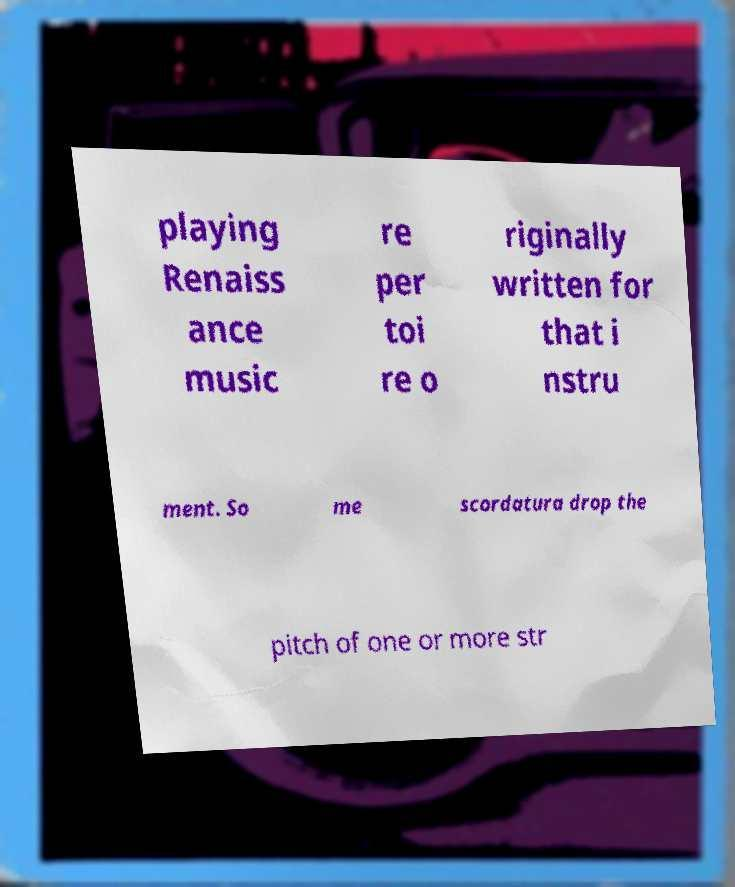Could you extract and type out the text from this image? playing Renaiss ance music re per toi re o riginally written for that i nstru ment. So me scordatura drop the pitch of one or more str 